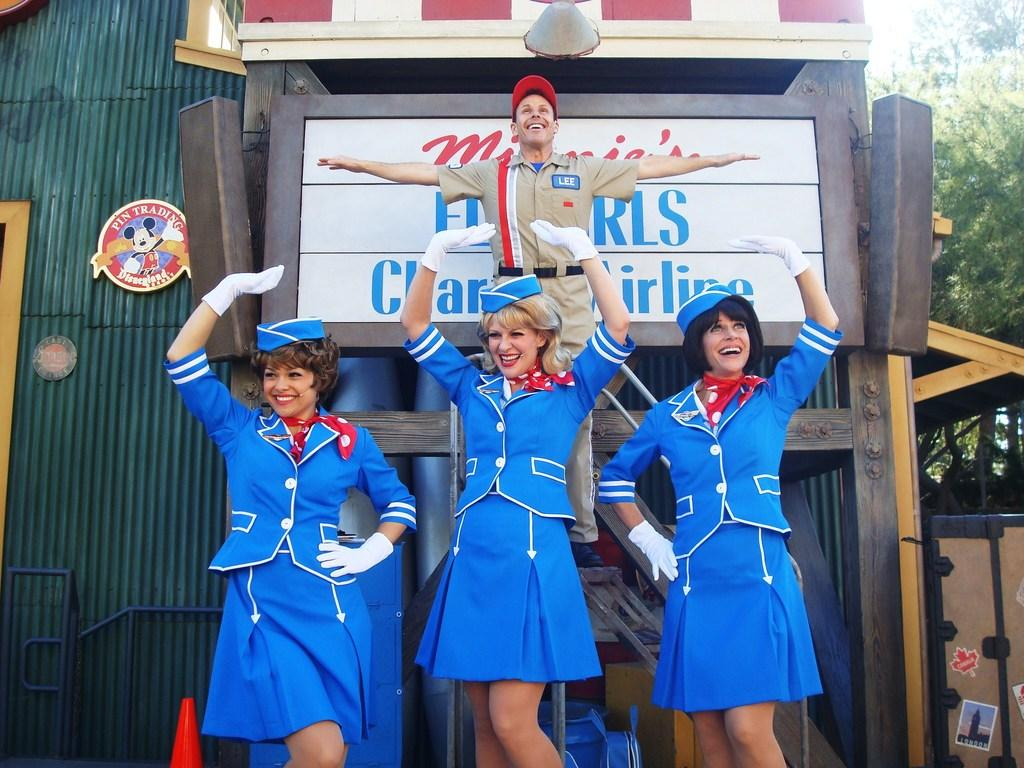<image>
Relay a brief, clear account of the picture shown. People are posing near a small round sing that says pin trading Disneyland on it. 